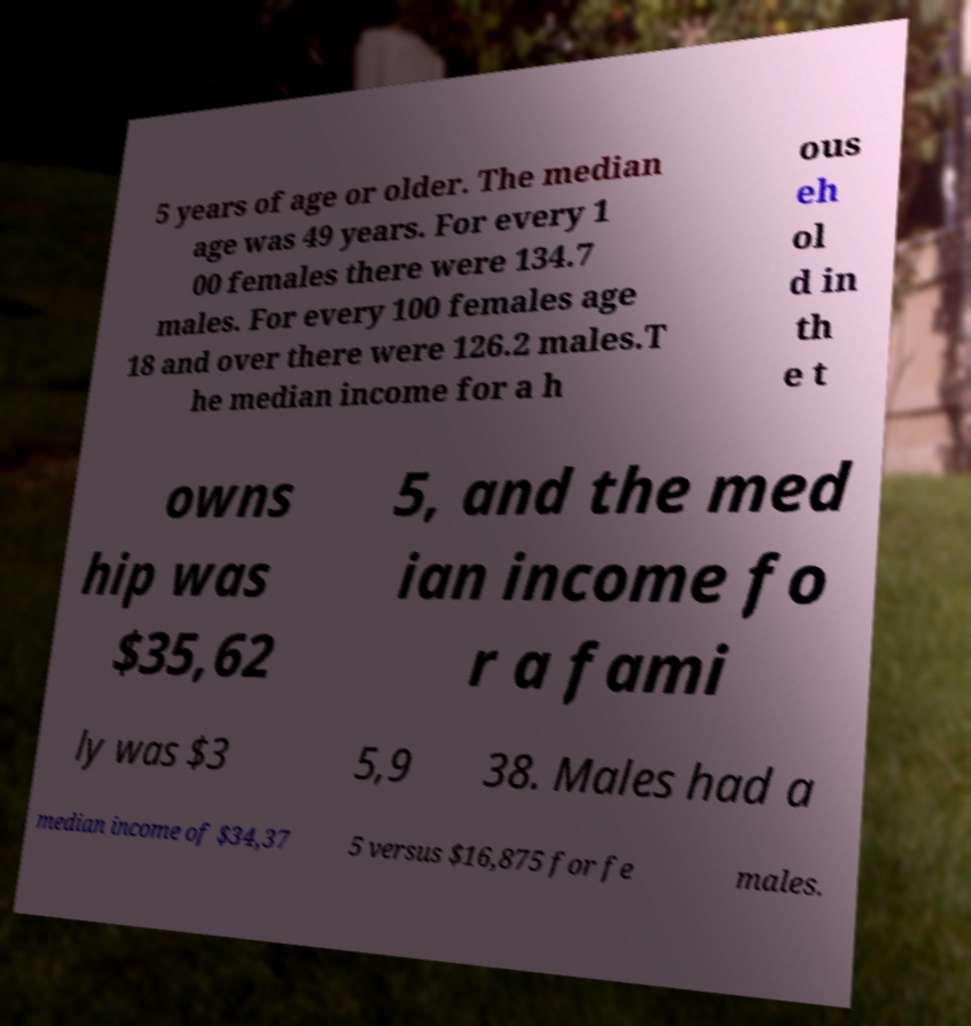Can you read and provide the text displayed in the image?This photo seems to have some interesting text. Can you extract and type it out for me? 5 years of age or older. The median age was 49 years. For every 1 00 females there were 134.7 males. For every 100 females age 18 and over there were 126.2 males.T he median income for a h ous eh ol d in th e t owns hip was $35,62 5, and the med ian income fo r a fami ly was $3 5,9 38. Males had a median income of $34,37 5 versus $16,875 for fe males. 